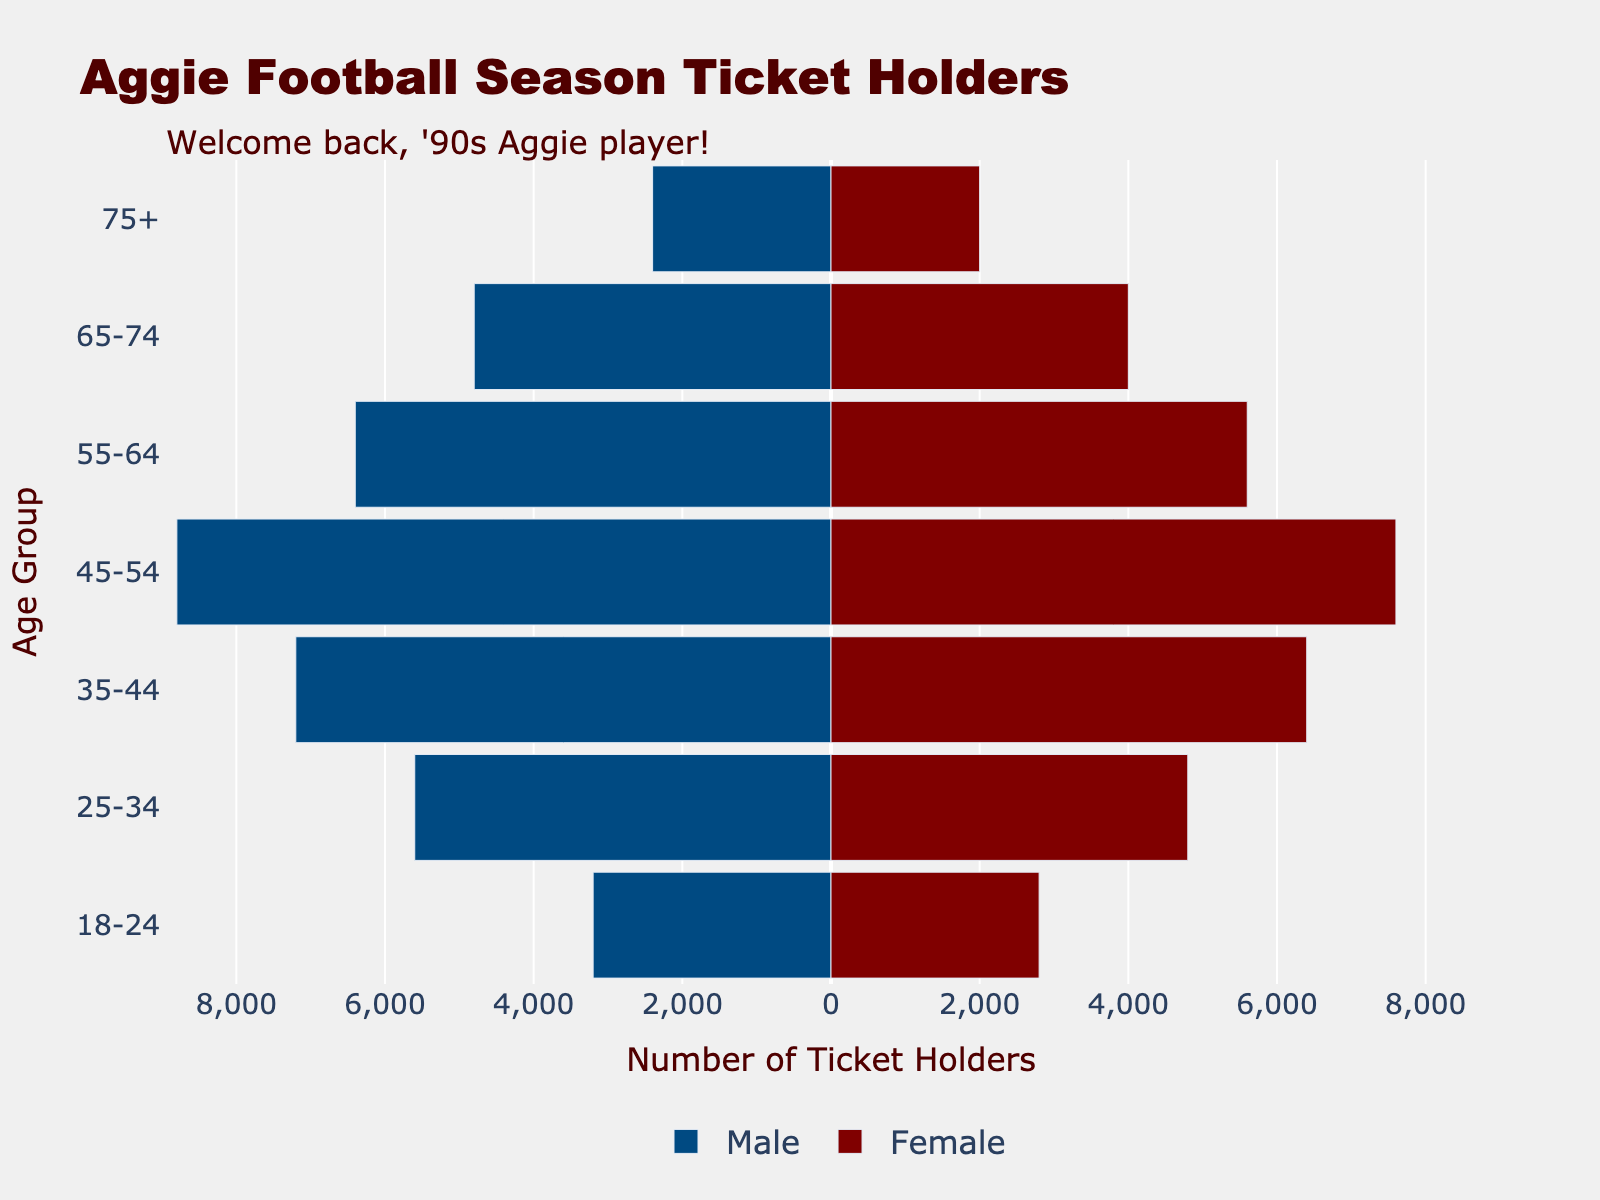What is the title of the figure? The title of the figure is located at the top and usually provides a brief overview of what the figure is about. In this case, the title reads "Aggie Football Season Ticket Holders".
Answer: Aggie Football Season Ticket Holders How many age groups are represented in the figure? By looking at the Y-axis, we can count the distinct age ranges provided which represent different age groups. These are: "18-24", "25-34", "35-44", "45-54", "55-64", "65-74", and "75+".
Answer: 7 Which age group has the highest number of male ticket holders? To identify the age group with the highest number of male ticket holders, examine the bars on the left side (representing males) and find the longest bar. The bar for the age group "45-54" is the longest.
Answer: 45-54 What is the total number of ticket holders aged 55-64? To find the total number of ticket holders aged 55-64, sum the number of male and female ticket holders in this age group. Males: 6400, Females: 5600, Total: 6400 + 5600.
Answer: 12000 Compare the number of female ticket holders aged 25-34 and 35-44. Which group has more? To compare, look at the bars representing females for these age groups. For the "25-34" group, the value is 4800. For the "35-44" group, the value is 6400.
Answer: 35-44 What is the difference in the number of male ticket holders between the age groups 45-54 and 65-74? To find the difference, subtract the number of male ticket holders in the age group "65-74" from the number in the age group "45-54". 8800 (45-54) - 4800 (65-74).
Answer: 4000 Which gender has more ticket holders aged 75+? To determine which gender has more ticket holders in the age group "75+", compare the values for males and females. Males: 2400, Females: 2000.
Answer: Male What is the average number of female ticket holders across all age groups? To calculate the average, sum the number of female ticket holders in all age groups and divide by the total number of age groups. (2800 + 4800 + 6400 + 7600 + 5600 + 4000 + 2000) / 7.
Answer: 4742.86 Is there an age group where the number of male and female ticket holders are equal? Check each age group to see if the number of male and female ticket holders are the same. From the figure, no age group has equal numbers for both genders.
Answer: No What is the median number of male ticket holders across all age groups? To find the median, first, list the number of male ticket holders in order: 2400, 3200, 4800, 5600, 6400, 7200, 8800. The median is the middle value.
Answer: 5600 